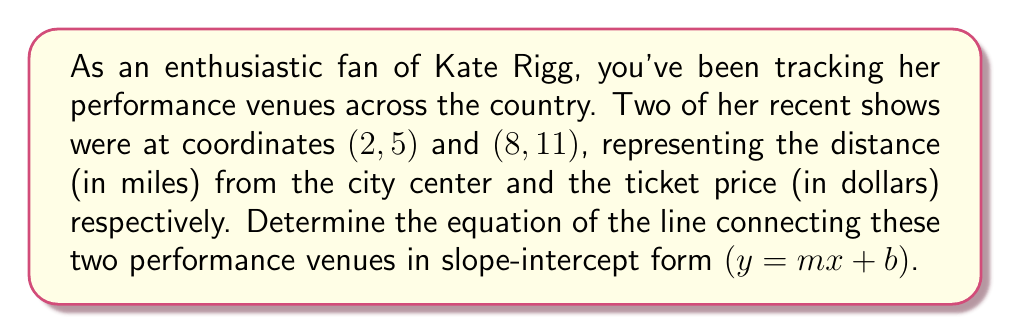Can you answer this question? To find the equation of the line connecting two points, we'll use the point-slope form and then convert it to slope-intercept form. Let's approach this step-by-step:

1. Calculate the slope $(m)$ using the slope formula:
   $$m = \frac{y_2 - y_1}{x_2 - x_1} = \frac{11 - 5}{8 - 2} = \frac{6}{6} = 1$$

2. Use either point and the calculated slope in the point-slope form:
   $y - y_1 = m(x - x_1)$
   Let's use (2, 5): $y - 5 = 1(x - 2)$

3. Expand the equation:
   $y - 5 = x - 2$

4. Add 5 to both sides to isolate $y$:
   $y = x - 2 + 5$

5. Simplify to get the slope-intercept form:
   $y = x + 3$

Therefore, the equation of the line connecting Kate Rigg's performance venues is $y = x + 3$, where $x$ represents the distance from the city center in miles, and $y$ represents the ticket price in dollars.
Answer: $y = x + 3$ 